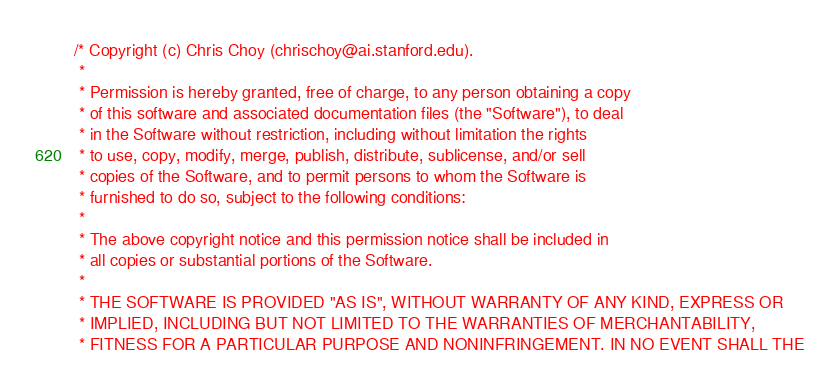<code> <loc_0><loc_0><loc_500><loc_500><_Cuda_>/* Copyright (c) Chris Choy (chrischoy@ai.stanford.edu).
 *
 * Permission is hereby granted, free of charge, to any person obtaining a copy
 * of this software and associated documentation files (the "Software"), to deal
 * in the Software without restriction, including without limitation the rights
 * to use, copy, modify, merge, publish, distribute, sublicense, and/or sell
 * copies of the Software, and to permit persons to whom the Software is
 * furnished to do so, subject to the following conditions:
 *
 * The above copyright notice and this permission notice shall be included in
 * all copies or substantial portions of the Software.
 *
 * THE SOFTWARE IS PROVIDED "AS IS", WITHOUT WARRANTY OF ANY KIND, EXPRESS OR
 * IMPLIED, INCLUDING BUT NOT LIMITED TO THE WARRANTIES OF MERCHANTABILITY,
 * FITNESS FOR A PARTICULAR PURPOSE AND NONINFRINGEMENT. IN NO EVENT SHALL THE</code> 